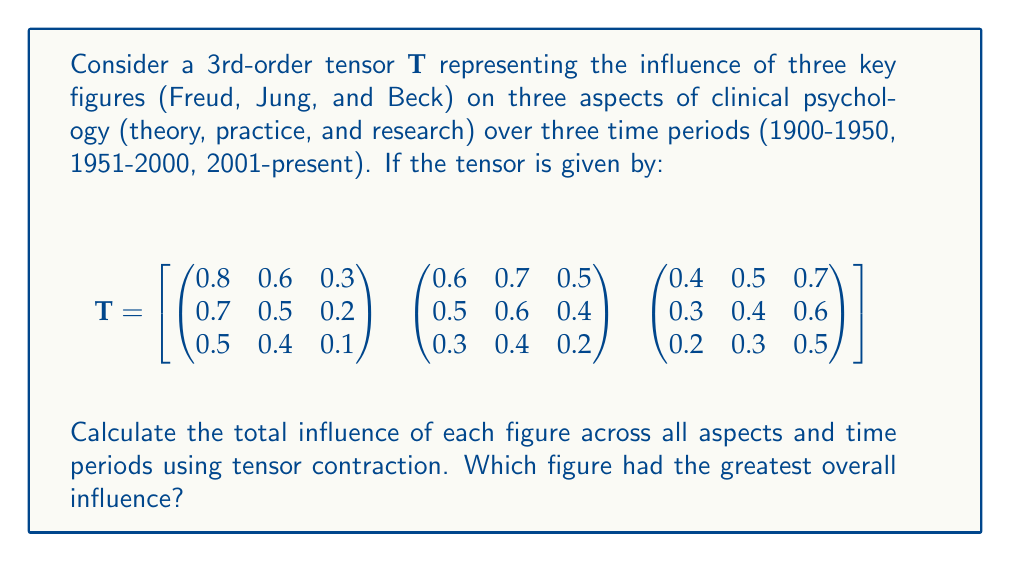Show me your answer to this math problem. To solve this problem, we need to perform tensor contraction on the given 3rd-order tensor. This will sum up the influence of each figure across all aspects and time periods.

Step 1: Identify the tensor dimensions
- Dimension 1: Key figures (Freud, Jung, Beck)
- Dimension 2: Aspects of clinical psychology (theory, practice, research)
- Dimension 3: Time periods (1900-1950, 1951-2000, 2001-present)

Step 2: Perform tensor contraction
We need to sum over dimensions 2 and 3 to get the total influence for each figure. This is equivalent to summing all elements in each 2D matrix for each figure.

For Freud (first 2D matrix):
$0.8 + 0.6 + 0.3 + 0.7 + 0.5 + 0.2 + 0.5 + 0.4 + 0.1 = 4.1$

For Jung (second 2D matrix):
$0.6 + 0.7 + 0.5 + 0.5 + 0.6 + 0.4 + 0.3 + 0.4 + 0.2 = 4.2$

For Beck (third 2D matrix):
$0.4 + 0.5 + 0.7 + 0.3 + 0.4 + 0.6 + 0.2 + 0.3 + 0.5 = 3.9$

Step 3: Compare the results
Freud: 4.1
Jung: 4.2
Beck: 3.9

Jung has the highest total influence of 4.2.
Answer: Jung, with a total influence of 4.2. 